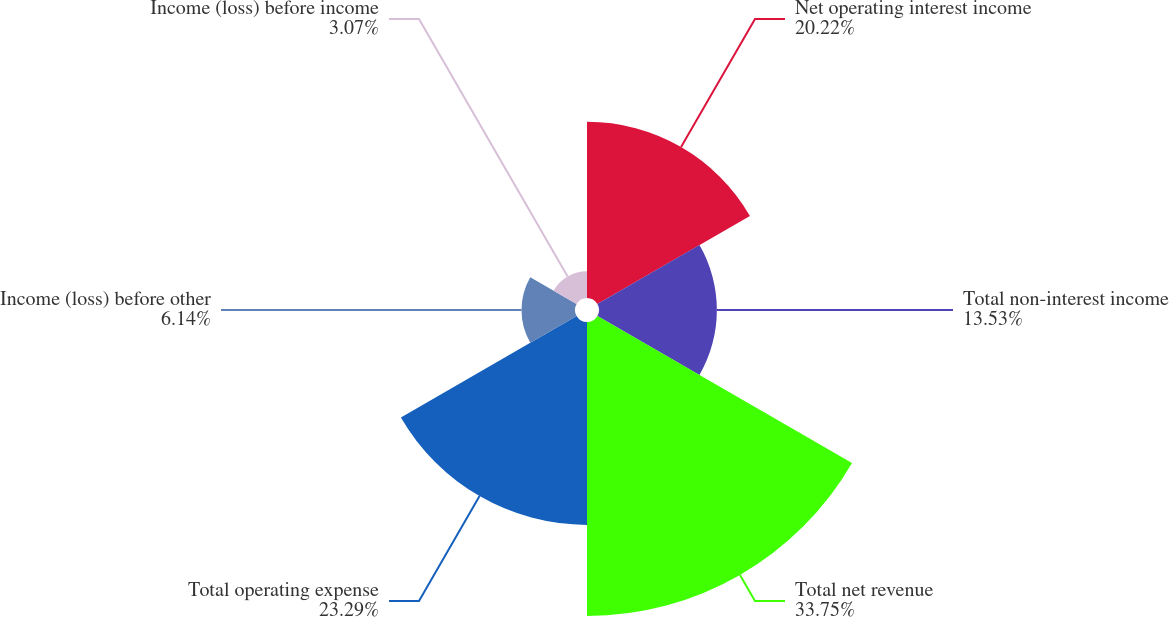<chart> <loc_0><loc_0><loc_500><loc_500><pie_chart><fcel>Net operating interest income<fcel>Total non-interest income<fcel>Total net revenue<fcel>Total operating expense<fcel>Income (loss) before other<fcel>Income (loss) before income<nl><fcel>20.22%<fcel>13.53%<fcel>33.75%<fcel>23.29%<fcel>6.14%<fcel>3.07%<nl></chart> 